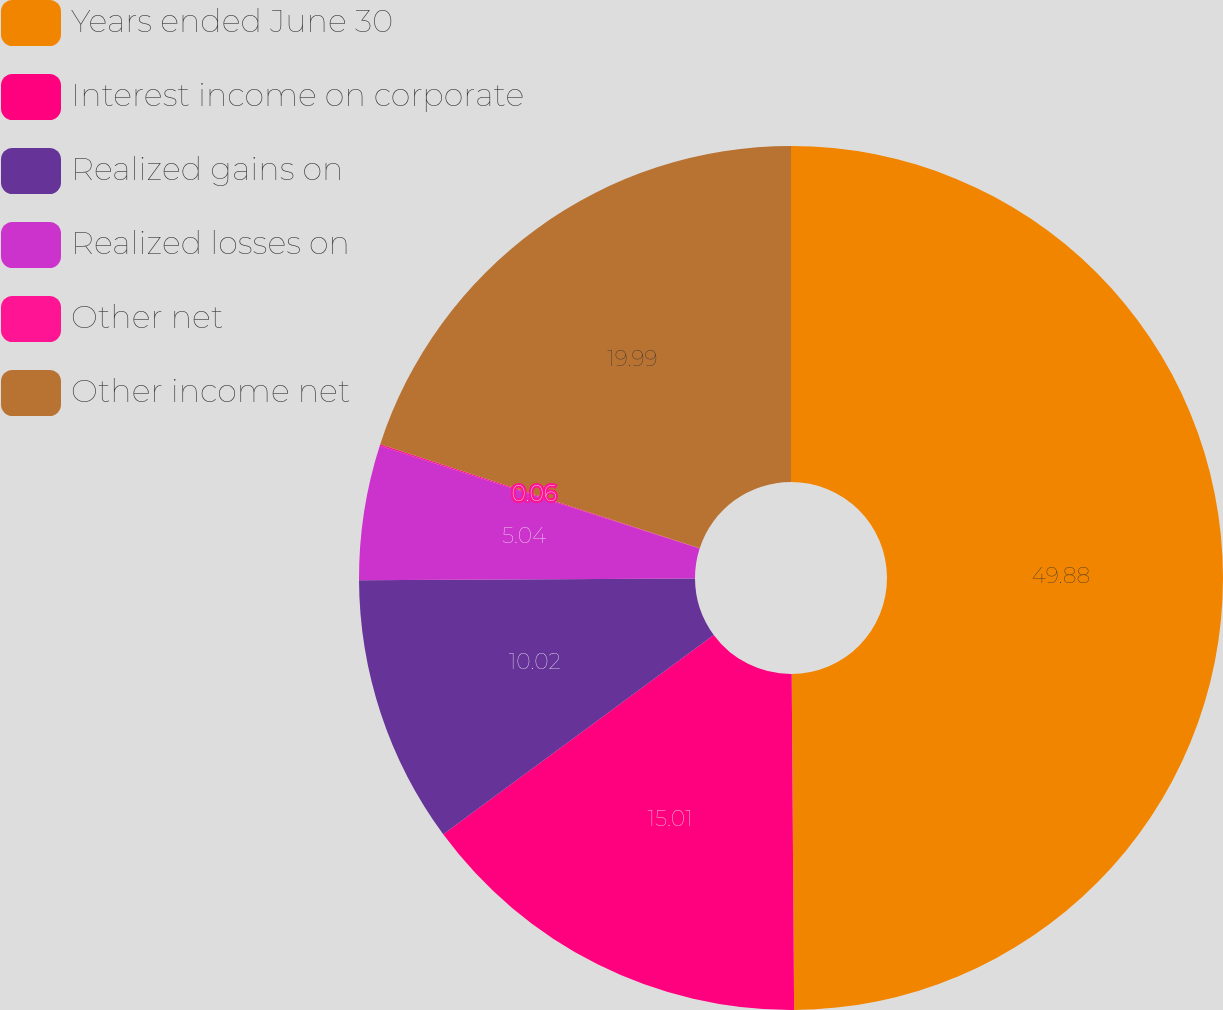Convert chart. <chart><loc_0><loc_0><loc_500><loc_500><pie_chart><fcel>Years ended June 30<fcel>Interest income on corporate<fcel>Realized gains on<fcel>Realized losses on<fcel>Other net<fcel>Other income net<nl><fcel>49.89%<fcel>15.01%<fcel>10.02%<fcel>5.04%<fcel>0.06%<fcel>19.99%<nl></chart> 